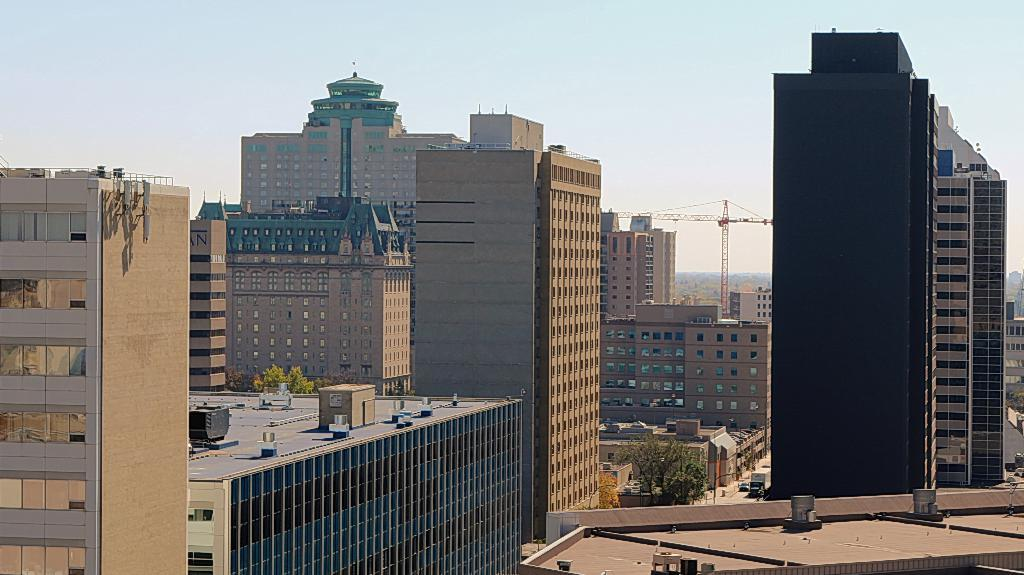What is the primary subject of the image? The primary subject of the image is the many buildings. Can you describe anything unusual in the road? Yes, there is a tree in the middle of the road. What else can be seen near the tree? There are vehicles visible beside the tree. What type of brass instrument can be seen being played by the tree in the image? There is no brass instrument or person playing an instrument in the image; it features a tree in the middle of the road and vehicles beside it. 